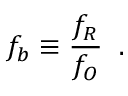<formula> <loc_0><loc_0><loc_500><loc_500>{ f _ { b } } \equiv \frac { f _ { R } } { f _ { O } } \, .</formula> 